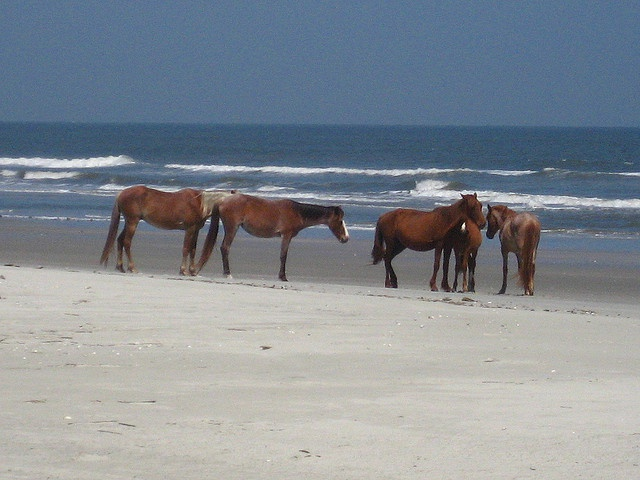Describe the objects in this image and their specific colors. I can see horse in gray, black, and maroon tones, horse in gray, maroon, black, and brown tones, horse in gray, maroon, brown, and black tones, horse in gray, black, and maroon tones, and horse in gray, black, and maroon tones in this image. 